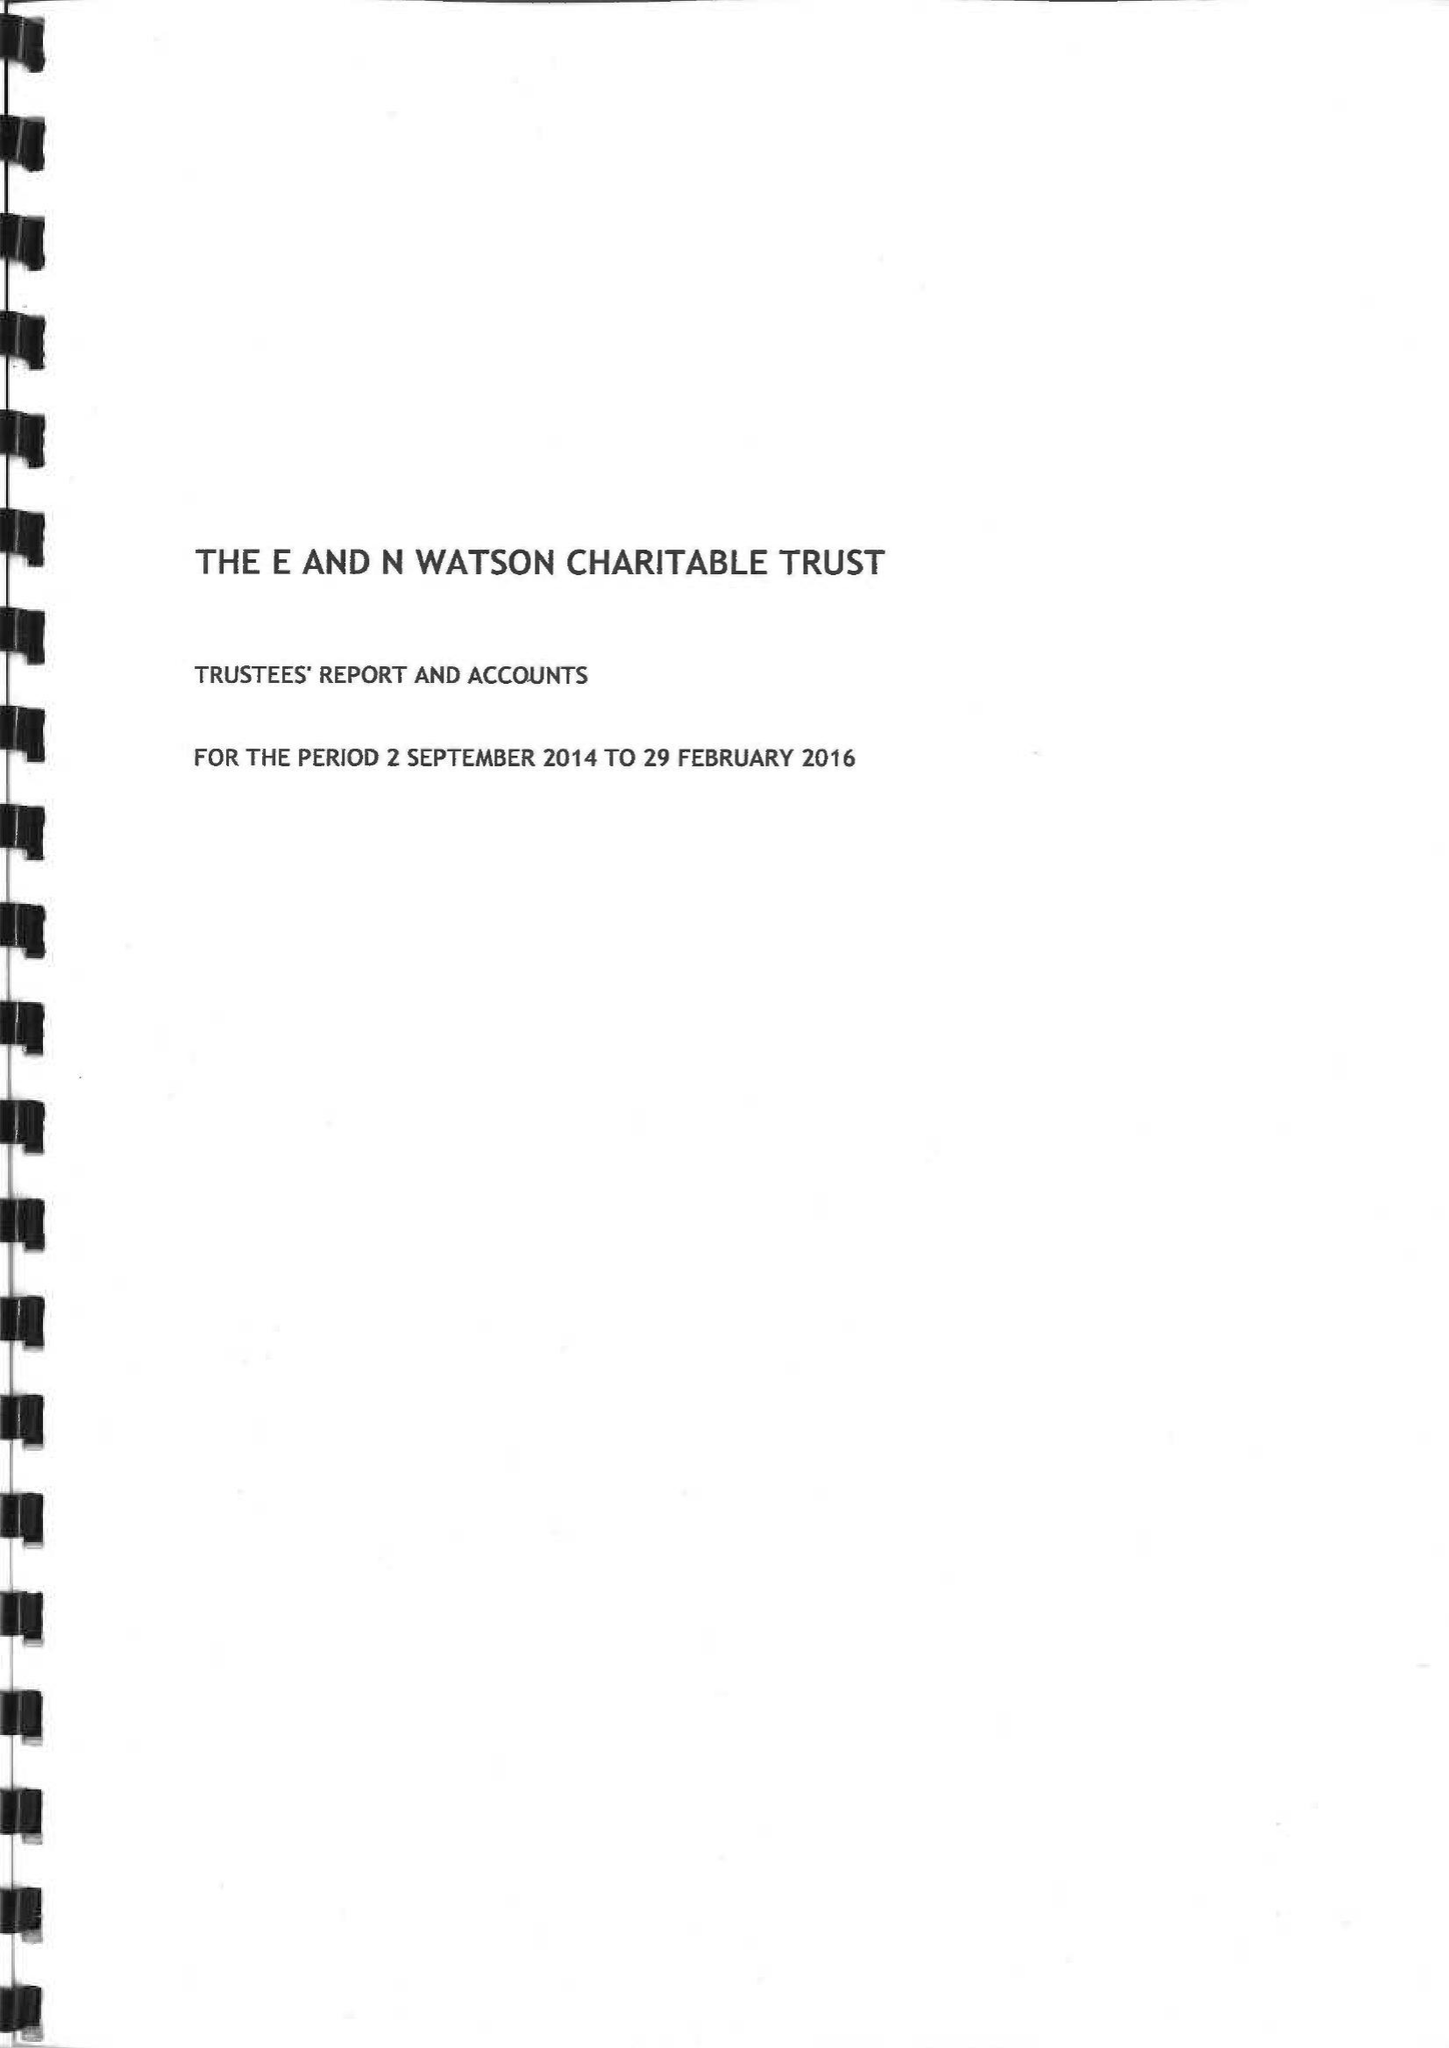What is the value for the address__street_line?
Answer the question using a single word or phrase. ST JOHNS STREET 